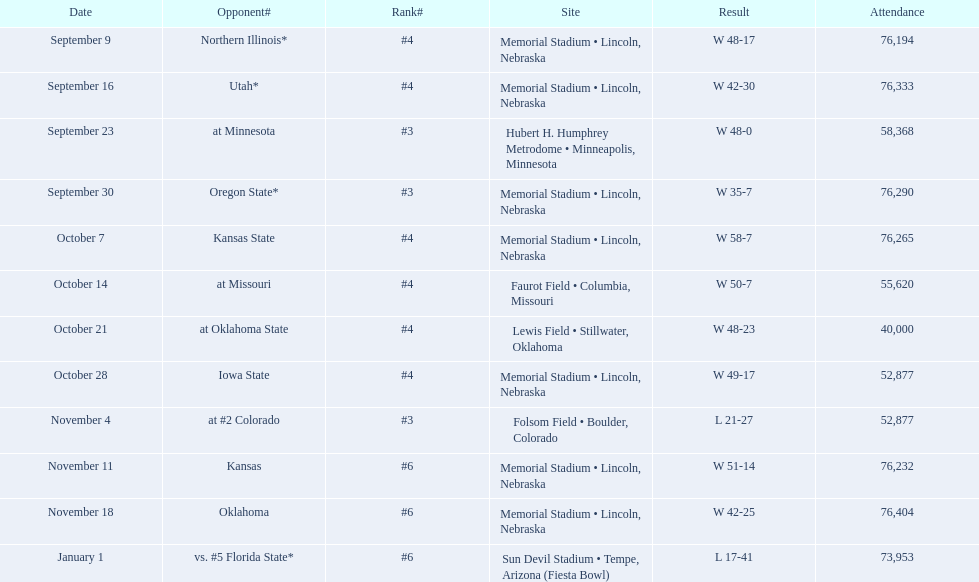Who were all their competitors? Northern Illinois*, Utah*, at Minnesota, Oregon State*, Kansas State, at Missouri, at Oklahoma State, Iowa State, at #2 Colorado, Kansas, Oklahoma, vs. #5 Florida State*. And what was the participation in these games? 76,194, 76,333, 58,368, 76,290, 76,265, 55,620, 40,000, 52,877, 52,877, 76,232, 76,404, 73,953. Of those numbers, which is related to the oregon state game? 76,290. 